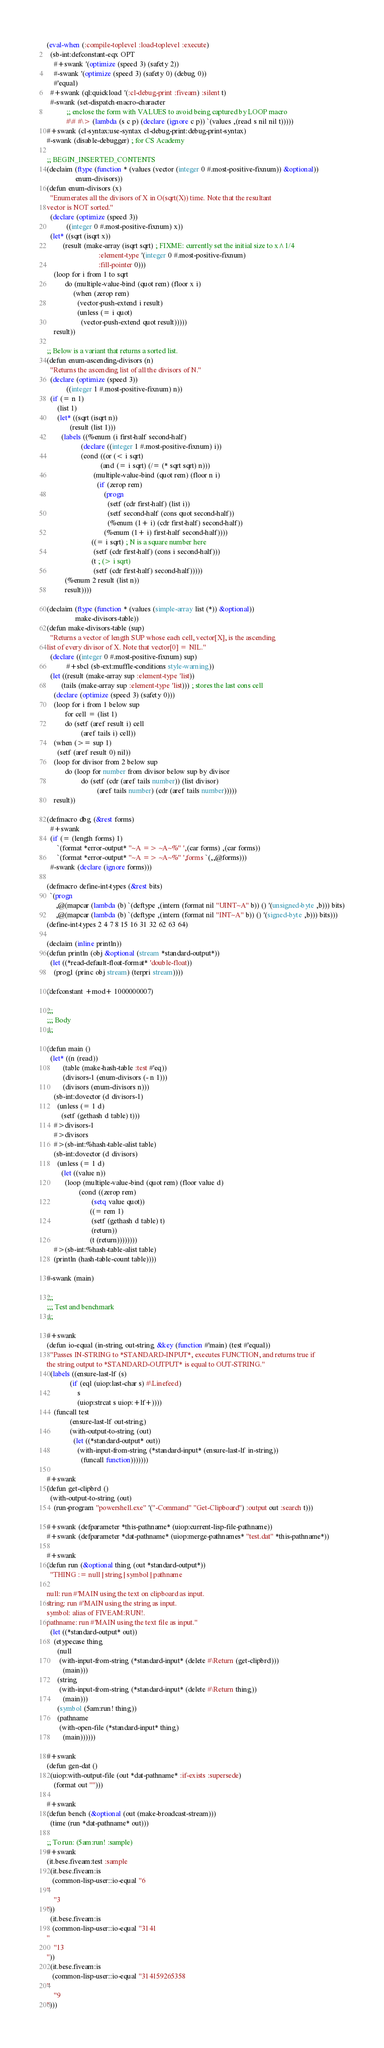<code> <loc_0><loc_0><loc_500><loc_500><_Lisp_>(eval-when (:compile-toplevel :load-toplevel :execute)
  (sb-int:defconstant-eqx OPT
    #+swank '(optimize (speed 3) (safety 2))
    #-swank '(optimize (speed 3) (safety 0) (debug 0))
    #'equal)
  #+swank (ql:quickload '(:cl-debug-print :fiveam) :silent t)
  #-swank (set-dispatch-macro-character
           ;; enclose the form with VALUES to avoid being captured by LOOP macro
           #\# #\> (lambda (s c p) (declare (ignore c p)) `(values ,(read s nil nil t)))))
#+swank (cl-syntax:use-syntax cl-debug-print:debug-print-syntax)
#-swank (disable-debugger) ; for CS Academy

;; BEGIN_INSERTED_CONTENTS
(declaim (ftype (function * (values (vector (integer 0 #.most-positive-fixnum)) &optional))
                enum-divisors))
(defun enum-divisors (x)
  "Enumerates all the divisors of X in O(sqrt(X)) time. Note that the resultant
vector is NOT sorted."
  (declare (optimize (speed 3))
           ((integer 0 #.most-positive-fixnum) x))
  (let* ((sqrt (isqrt x))
         (result (make-array (isqrt sqrt) ; FIXME: currently set the initial size to x^1/4
                             :element-type '(integer 0 #.most-positive-fixnum)
                             :fill-pointer 0)))
    (loop for i from 1 to sqrt
          do (multiple-value-bind (quot rem) (floor x i)
               (when (zerop rem)
                 (vector-push-extend i result)
                 (unless (= i quot)
                   (vector-push-extend quot result)))))
    result))

;; Below is a variant that returns a sorted list.
(defun enum-ascending-divisors (n)
  "Returns the ascending list of all the divisors of N."
  (declare (optimize (speed 3))
           ((integer 1 #.most-positive-fixnum) n))
  (if (= n 1)
      (list 1)
      (let* ((sqrt (isqrt n))
             (result (list 1)))
        (labels ((%enum (i first-half second-half)
                   (declare ((integer 1 #.most-positive-fixnum) i))
                   (cond ((or (< i sqrt)
                              (and (= i sqrt) (/= (* sqrt sqrt) n)))
                          (multiple-value-bind (quot rem) (floor n i)
                            (if (zerop rem)
                                (progn
                                  (setf (cdr first-half) (list i))
                                  (setf second-half (cons quot second-half))
                                  (%enum (1+ i) (cdr first-half) second-half))
                                (%enum (1+ i) first-half second-half))))
                         ((= i sqrt) ; N is a square number here
                          (setf (cdr first-half) (cons i second-half)))
                         (t ; (> i sqrt)
                          (setf (cdr first-half) second-half)))))
          (%enum 2 result (list n))
          result))))

(declaim (ftype (function * (values (simple-array list (*)) &optional))
                make-divisors-table))
(defun make-divisors-table (sup)
  "Returns a vector of length SUP whose each cell, vector[X], is the ascending
list of every divisor of X. Note that vector[0] = NIL."
  (declare ((integer 0 #.most-positive-fixnum) sup)
           #+sbcl (sb-ext:muffle-conditions style-warning))
  (let ((result (make-array sup :element-type 'list))
        (tails (make-array sup :element-type 'list))) ; stores the last cons cell
    (declare (optimize (speed 3) (safety 0)))
    (loop for i from 1 below sup
          for cell = (list 1)
          do (setf (aref result i) cell
                   (aref tails i) cell))
    (when (>= sup 1)
      (setf (aref result 0) nil))
    (loop for divisor from 2 below sup
          do (loop for number from divisor below sup by divisor
                   do (setf (cdr (aref tails number)) (list divisor)
                            (aref tails number) (cdr (aref tails number)))))
    result))

(defmacro dbg (&rest forms)
  #+swank
  (if (= (length forms) 1)
      `(format *error-output* "~A => ~A~%" ',(car forms) ,(car forms))
      `(format *error-output* "~A => ~A~%" ',forms `(,,@forms)))
  #-swank (declare (ignore forms)))

(defmacro define-int-types (&rest bits)
  `(progn
     ,@(mapcar (lambda (b) `(deftype ,(intern (format nil "UINT~A" b)) () '(unsigned-byte ,b))) bits)
     ,@(mapcar (lambda (b) `(deftype ,(intern (format nil "INT~A" b)) () '(signed-byte ,b))) bits)))
(define-int-types 2 4 7 8 15 16 31 32 62 63 64)

(declaim (inline println))
(defun println (obj &optional (stream *standard-output*))
  (let ((*read-default-float-format* 'double-float))
    (prog1 (princ obj stream) (terpri stream))))

(defconstant +mod+ 1000000007)

;;;
;;; Body
;;;

(defun main ()
  (let* ((n (read))
         (table (make-hash-table :test #'eq))
         (divisors-1 (enum-divisors (- n 1)))
         (divisors (enum-divisors n)))
    (sb-int:dovector (d divisors-1)
      (unless (= 1 d)
        (setf (gethash d table) t)))
    #>divisors-1
    #>divisors
    #>(sb-int:%hash-table-alist table)
    (sb-int:dovector (d divisors)
      (unless (= 1 d)
        (let ((value n))
          (loop (multiple-value-bind (quot rem) (floor value d)
                  (cond ((zerop rem)
                         (setq value quot))
                        ((= rem 1)
                         (setf (gethash d table) t)
                         (return))
                        (t (return))))))))
    #>(sb-int:%hash-table-alist table)
    (println (hash-table-count table))))

#-swank (main)

;;;
;;; Test and benchmark
;;;

#+swank
(defun io-equal (in-string out-string &key (function #'main) (test #'equal))
  "Passes IN-STRING to *STANDARD-INPUT*, executes FUNCTION, and returns true if
the string output to *STANDARD-OUTPUT* is equal to OUT-STRING."
  (labels ((ensure-last-lf (s)
             (if (eql (uiop:last-char s) #\Linefeed)
                 s
                 (uiop:strcat s uiop:+lf+))))
    (funcall test
             (ensure-last-lf out-string)
             (with-output-to-string (out)
               (let ((*standard-output* out))
                 (with-input-from-string (*standard-input* (ensure-last-lf in-string))
                   (funcall function)))))))

#+swank
(defun get-clipbrd ()
  (with-output-to-string (out)
    (run-program "powershell.exe" '("-Command" "Get-Clipboard") :output out :search t)))

#+swank (defparameter *this-pathname* (uiop:current-lisp-file-pathname))
#+swank (defparameter *dat-pathname* (uiop:merge-pathnames* "test.dat" *this-pathname*))

#+swank
(defun run (&optional thing (out *standard-output*))
  "THING := null | string | symbol | pathname

null: run #'MAIN using the text on clipboard as input.
string: run #'MAIN using the string as input.
symbol: alias of FIVEAM:RUN!.
pathname: run #'MAIN using the text file as input."
  (let ((*standard-output* out))
    (etypecase thing
      (null
       (with-input-from-string (*standard-input* (delete #\Return (get-clipbrd)))
         (main)))
      (string
       (with-input-from-string (*standard-input* (delete #\Return thing))
         (main)))
      (symbol (5am:run! thing))
      (pathname
       (with-open-file (*standard-input* thing)
         (main))))))

#+swank
(defun gen-dat ()
  (uiop:with-output-file (out *dat-pathname* :if-exists :supersede)
    (format out "")))

#+swank
(defun bench (&optional (out (make-broadcast-stream)))
  (time (run *dat-pathname* out)))

;; To run: (5am:run! :sample)
#+swank
(it.bese.fiveam:test :sample
  (it.bese.fiveam:is
   (common-lisp-user::io-equal "6
"
    "3
"))
  (it.bese.fiveam:is
   (common-lisp-user::io-equal "3141
"
    "13
"))
  (it.bese.fiveam:is
   (common-lisp-user::io-equal "314159265358
"
    "9
")))
</code> 